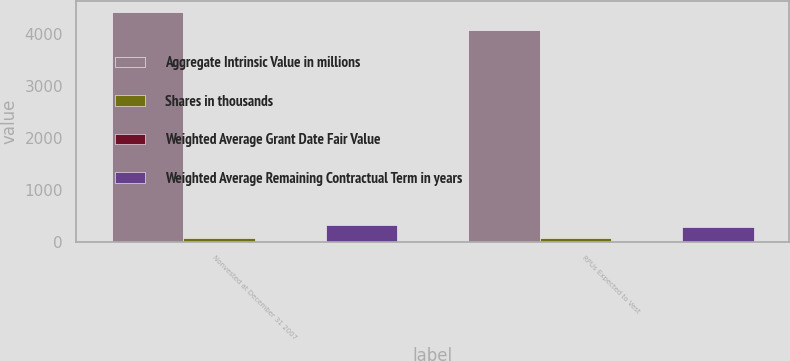Convert chart to OTSL. <chart><loc_0><loc_0><loc_500><loc_500><stacked_bar_chart><ecel><fcel>Nonvested at December 31 2007<fcel>RPUs Expected to Vest<nl><fcel>Aggregate Intrinsic Value in millions<fcel>4417<fcel>4062<nl><fcel>Shares in thousands<fcel>71.5<fcel>71.44<nl><fcel>Weighted Average Grant Date Fair Value<fcel>2.47<fcel>2.33<nl><fcel>Weighted Average Remaining Contractual Term in years<fcel>312<fcel>287<nl></chart> 